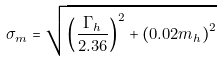Convert formula to latex. <formula><loc_0><loc_0><loc_500><loc_500>\sigma _ { m } = \sqrt { \left ( \frac { \Gamma _ { h } } { 2 . 3 6 } \right ) ^ { 2 } + \left ( 0 . 0 2 m _ { h } \right ) ^ { 2 } }</formula> 